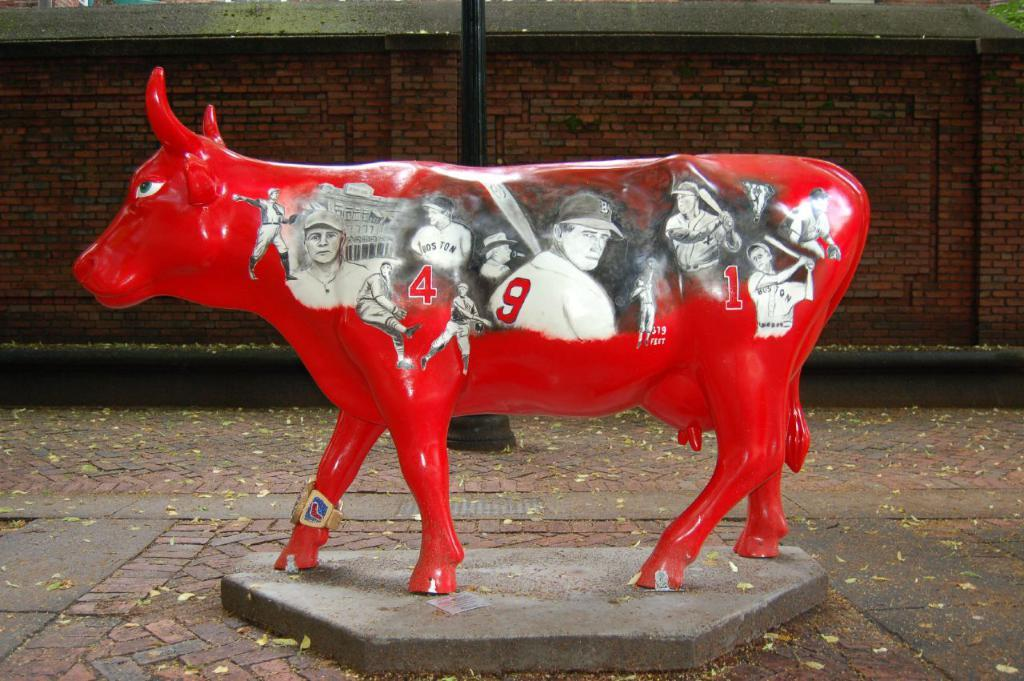What is the main subject of the image? The main subject of the image is a statue. What can be seen on the statue? The statue has pictures of people and numbers on it. What else is visible in the image besides the statue? There is a pole and a wall visible in the image. How many balls are being juggled by the passenger in the image? There is no passenger or balls present in the image; it features a statue with pictures of people and numbers on it. 